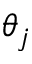<formula> <loc_0><loc_0><loc_500><loc_500>\theta _ { j }</formula> 